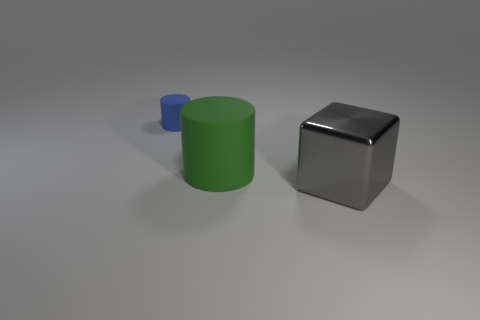Are there any other red cubes that have the same size as the metal block?
Your answer should be compact. No. There is a cylinder on the left side of the green rubber object; is it the same size as the metal block?
Ensure brevity in your answer.  No. Is the number of large green objects on the right side of the big cylinder greater than the number of big cylinders?
Your answer should be compact. No. The blue object that is made of the same material as the big green object is what size?
Provide a short and direct response. Small. Is the color of the big thing that is in front of the big rubber cylinder the same as the large cylinder?
Offer a terse response. No. Is the number of large green things that are behind the big metallic block the same as the number of big green matte things behind the small blue object?
Provide a succinct answer. No. Is there any other thing that has the same material as the large gray cube?
Offer a very short reply. No. What is the color of the big object behind the big block?
Offer a very short reply. Green. Is the number of small blue cylinders to the right of the small blue thing the same as the number of red matte objects?
Ensure brevity in your answer.  Yes. What number of other objects are the same shape as the large gray thing?
Make the answer very short. 0. 